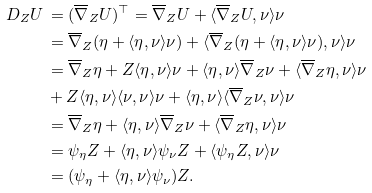<formula> <loc_0><loc_0><loc_500><loc_500>D _ { Z } U & \, = ( \overline { \nabla } _ { Z } U ) ^ { \top } = \overline { \nabla } _ { Z } U + \langle \overline { \nabla } _ { Z } U , \nu \rangle \nu \\ & \, = \overline { \nabla } _ { Z } ( \eta + \langle \eta , \nu \rangle \nu ) + \langle \overline { \nabla } _ { Z } ( \eta + \langle \eta , \nu \rangle \nu ) , \nu \rangle \nu \\ & \, = \overline { \nabla } _ { Z } \eta + Z \langle \eta , \nu \rangle \nu + \langle \eta , \nu \rangle \overline { \nabla } _ { Z } \nu + \langle \overline { \nabla } _ { Z } \eta , \nu \rangle \nu \\ & \, + Z \langle \eta , \nu \rangle \langle \nu , \nu \rangle \nu + \langle \eta , \nu \rangle \langle \overline { \nabla } _ { Z } \nu , \nu \rangle \nu \\ & \, = \overline { \nabla } _ { Z } \eta + \langle \eta , \nu \rangle \overline { \nabla } _ { Z } \nu + \langle \overline { \nabla } _ { Z } \eta , \nu \rangle \nu \\ & \, = \psi _ { \eta } Z + \langle \eta , \nu \rangle \psi _ { \nu } Z + \langle \psi _ { \eta } Z , \nu \rangle \nu \\ & \, = ( \psi _ { \eta } + \langle \eta , \nu \rangle \psi _ { \nu } ) Z .</formula> 